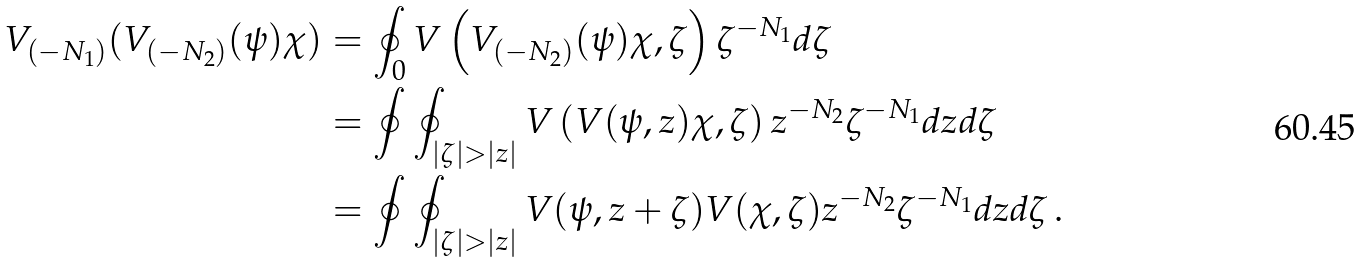Convert formula to latex. <formula><loc_0><loc_0><loc_500><loc_500>V _ { ( - N _ { 1 } ) } ( V _ { ( - N _ { 2 } ) } ( \psi ) \chi ) & = \oint _ { 0 } V \left ( V _ { ( - N _ { 2 } ) } ( \psi ) \chi , \zeta \right ) \zeta ^ { - N _ { 1 } } d \zeta \\ & = \oint \oint _ { | \zeta | > | z | } V \left ( V ( \psi , z ) \chi , \zeta \right ) z ^ { - N _ { 2 } } \zeta ^ { - N _ { 1 } } d z d \zeta \\ & = \oint \oint _ { | \zeta | > | z | } V ( \psi , z + \zeta ) V ( \chi , \zeta ) z ^ { - N _ { 2 } } \zeta ^ { - N _ { 1 } } d z d \zeta \, .</formula> 